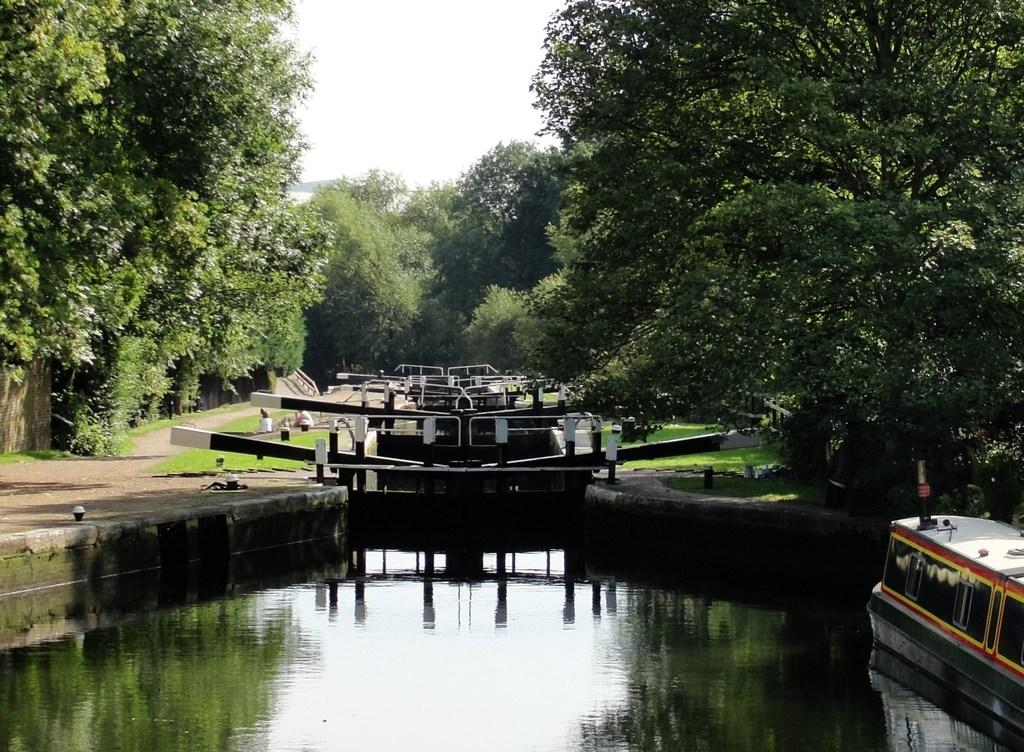What body of water is present in the image? There is a small lake in the image. Where is the boat located in the image? The boat is on the right side of the image. What can be seen in the backdrop of the image? There is an iron frame in the backdrop of the image. What type of vegetation is present in the image? There are trees in the image. What is the condition of the sky in the image? The sky is clear in the image. What type of scarf is being worn by the trees in the image? There are no scarves present in the image; it features a small lake, a boat, an iron frame, trees, and a clear sky. How many feet are visible in the image? There are no feet visible in the image. 